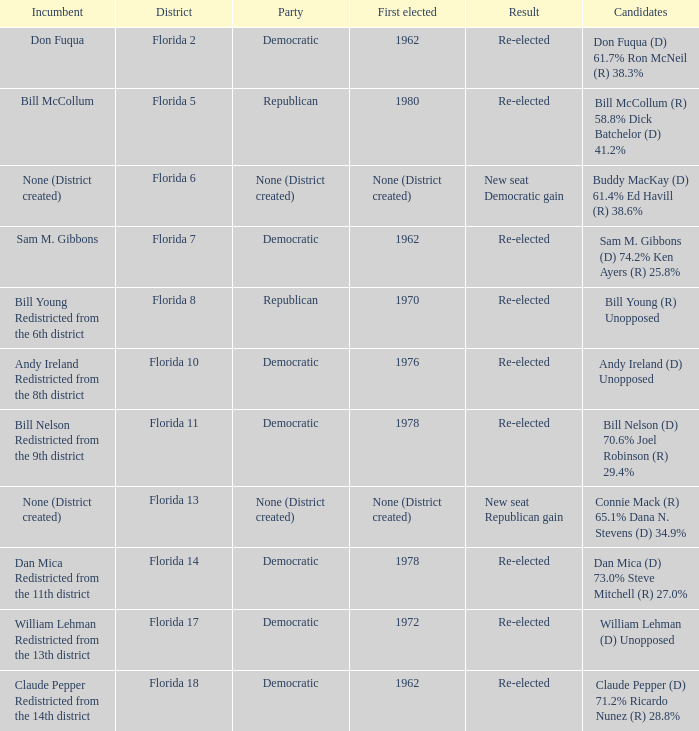 how many candidates with result being new seat democratic gain 1.0. 